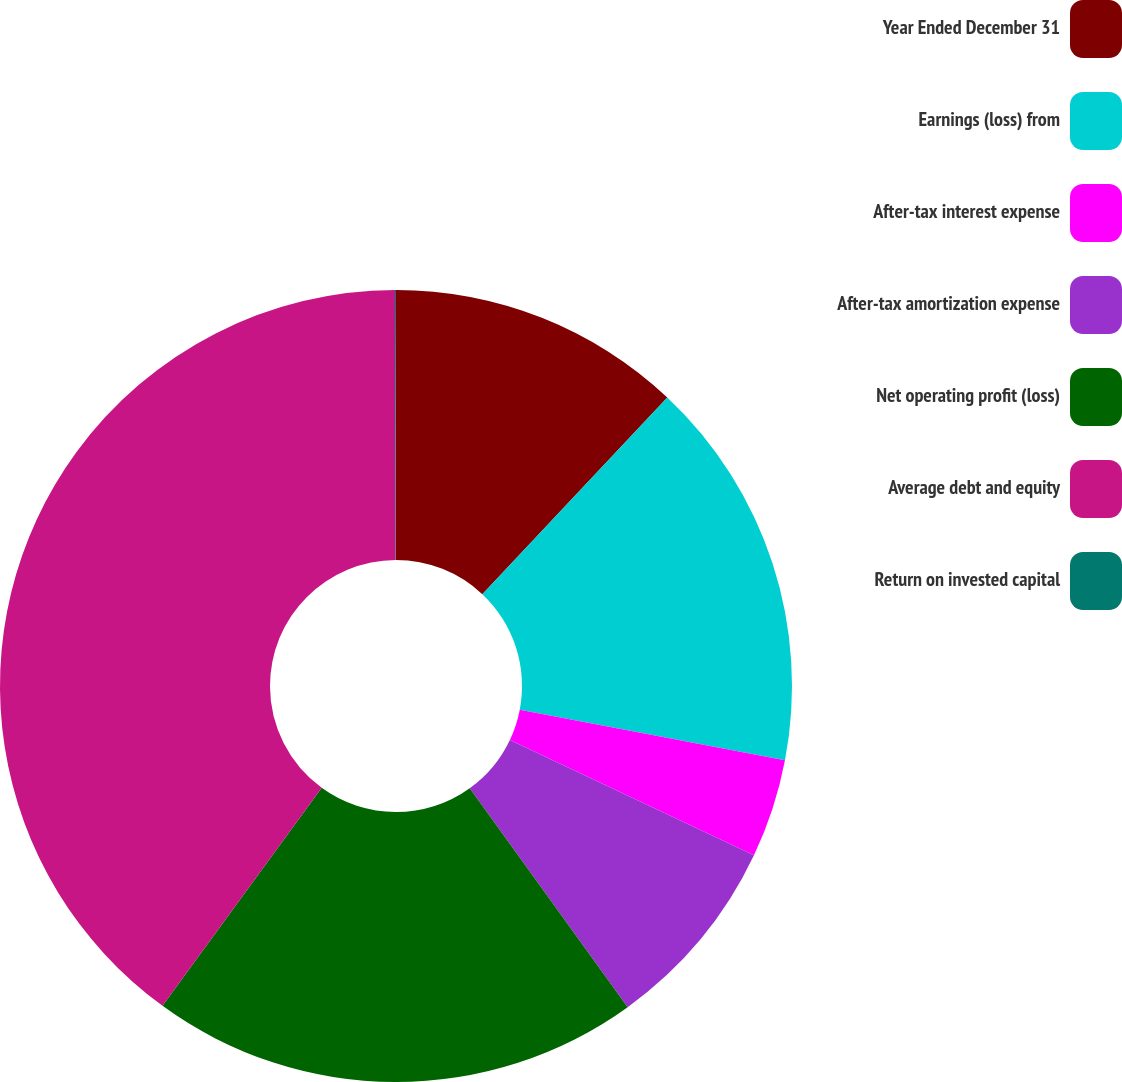Convert chart. <chart><loc_0><loc_0><loc_500><loc_500><pie_chart><fcel>Year Ended December 31<fcel>Earnings (loss) from<fcel>After-tax interest expense<fcel>After-tax amortization expense<fcel>Net operating profit (loss)<fcel>Average debt and equity<fcel>Return on invested capital<nl><fcel>12.01%<fcel>15.99%<fcel>4.03%<fcel>8.02%<fcel>19.98%<fcel>39.92%<fcel>0.04%<nl></chart> 